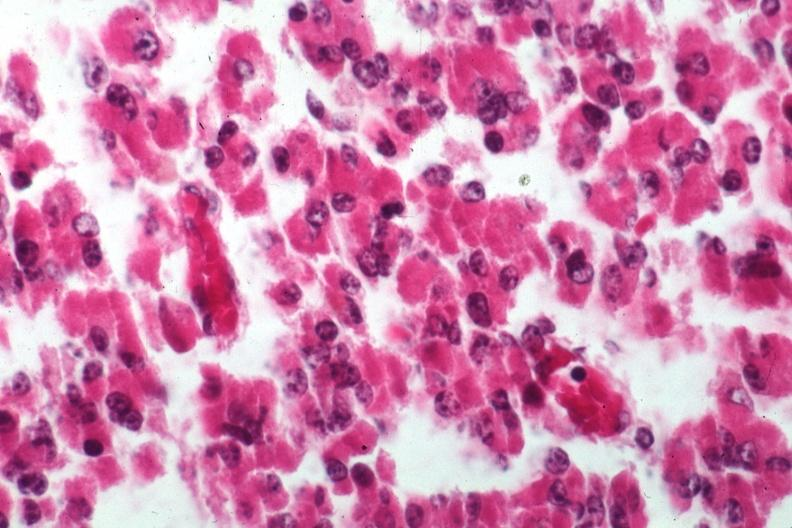what is present?
Answer the question using a single word or phrase. Endocrine 